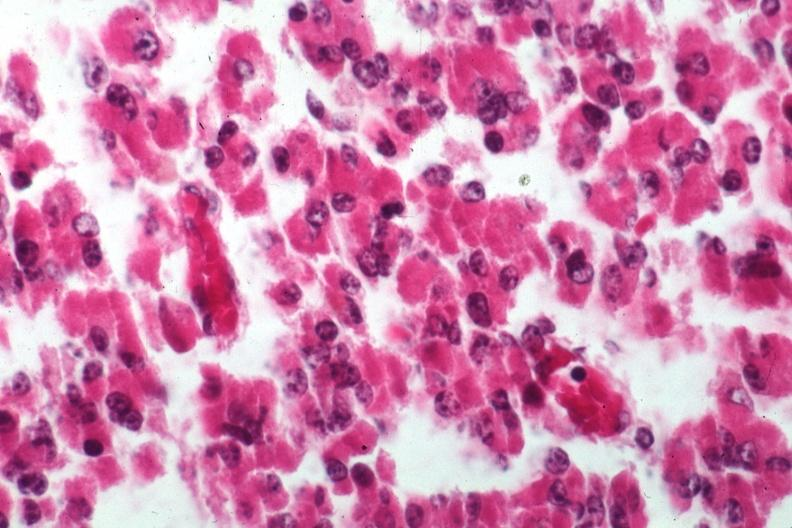what is present?
Answer the question using a single word or phrase. Endocrine 